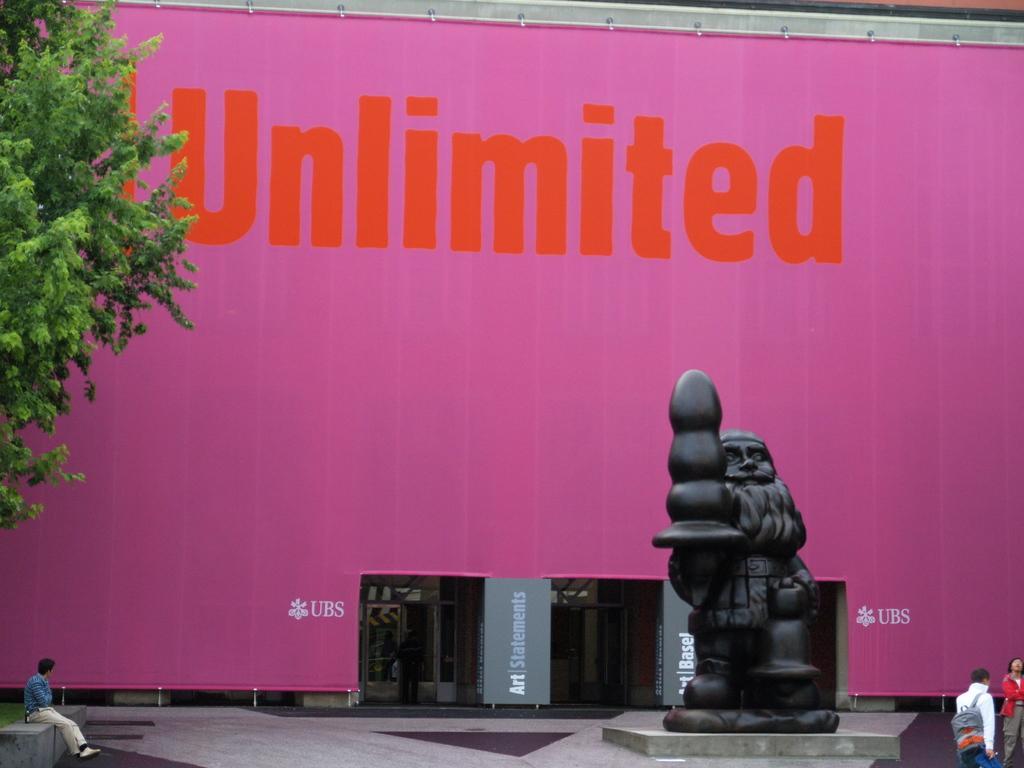Can you describe this image briefly? In this picture, we can see the ground, a few people, and we can see statue, wall with text, and we can see doors. 